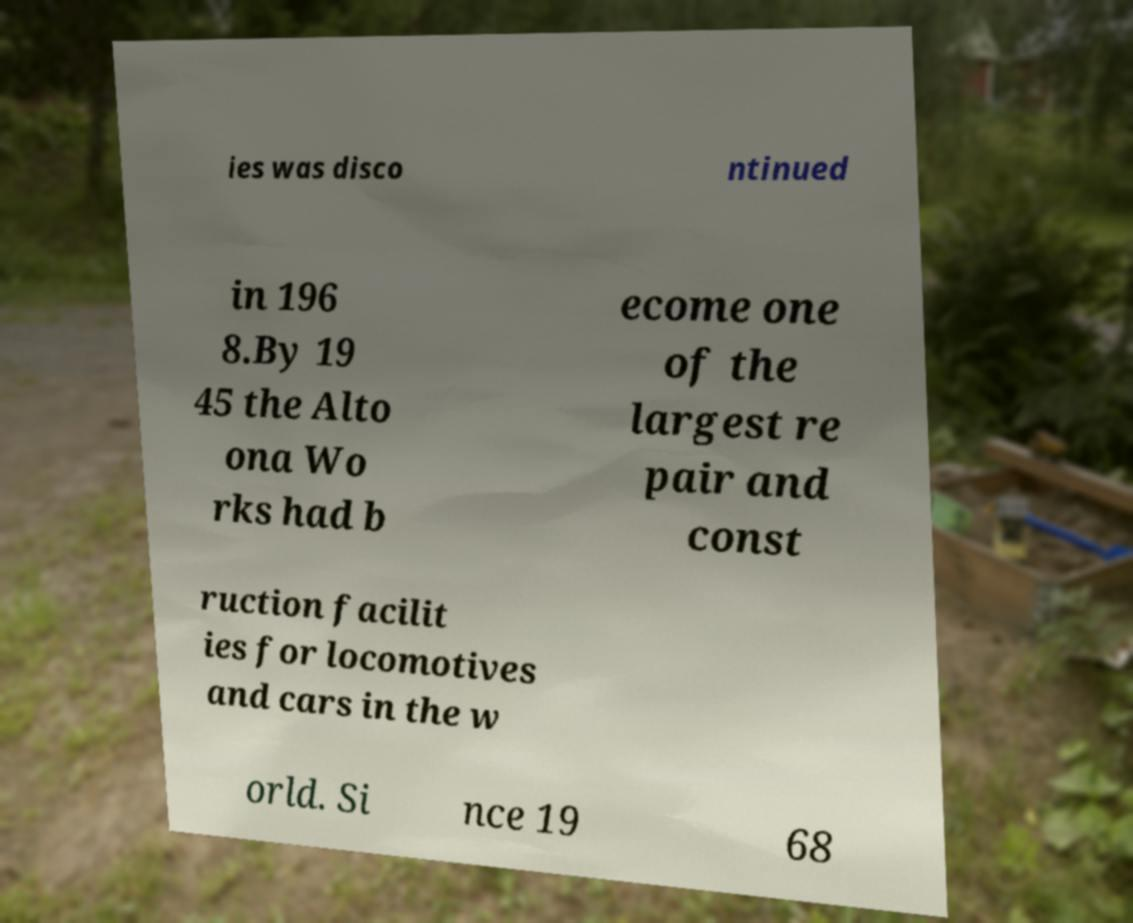Can you read and provide the text displayed in the image?This photo seems to have some interesting text. Can you extract and type it out for me? ies was disco ntinued in 196 8.By 19 45 the Alto ona Wo rks had b ecome one of the largest re pair and const ruction facilit ies for locomotives and cars in the w orld. Si nce 19 68 